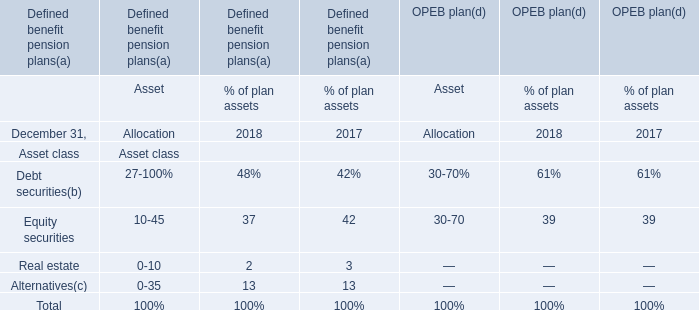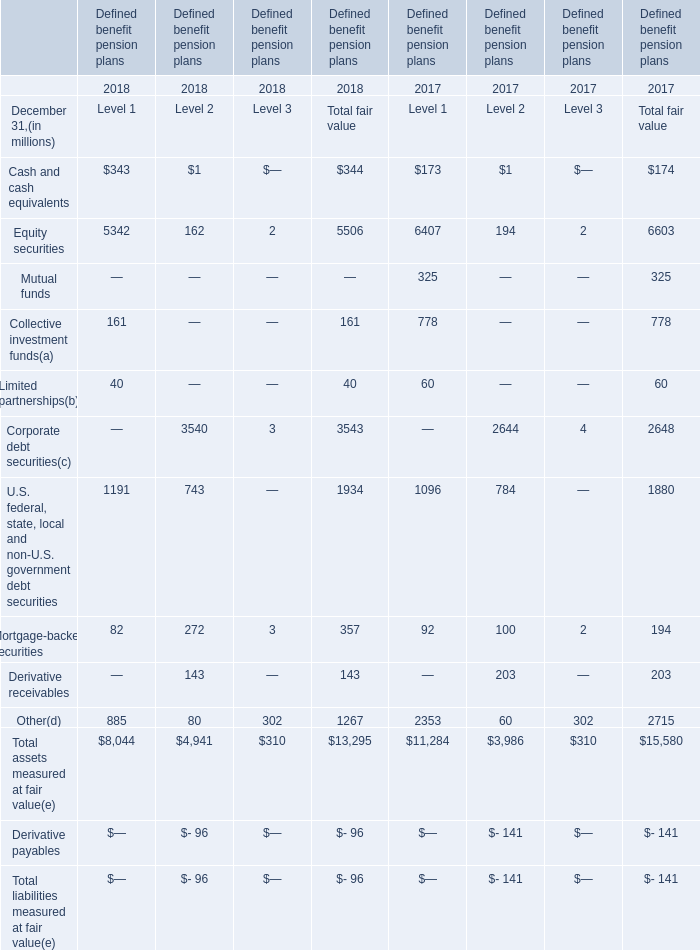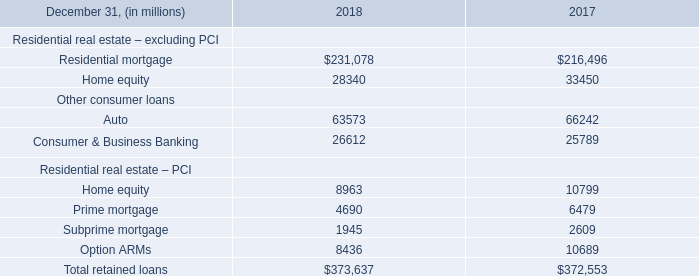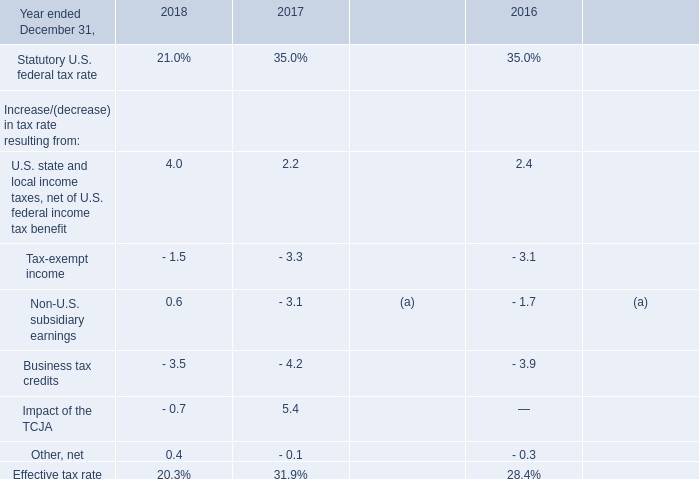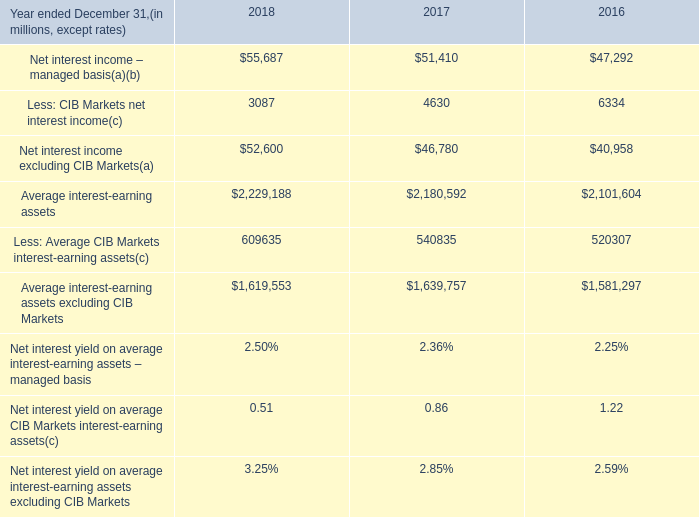by how many basis points did net interest yield on average interest-earning assets 2013 managed basis improve form 2017 to 2018? 
Computations: ((2.50 - 2.36) * 100)
Answer: 14.0. 